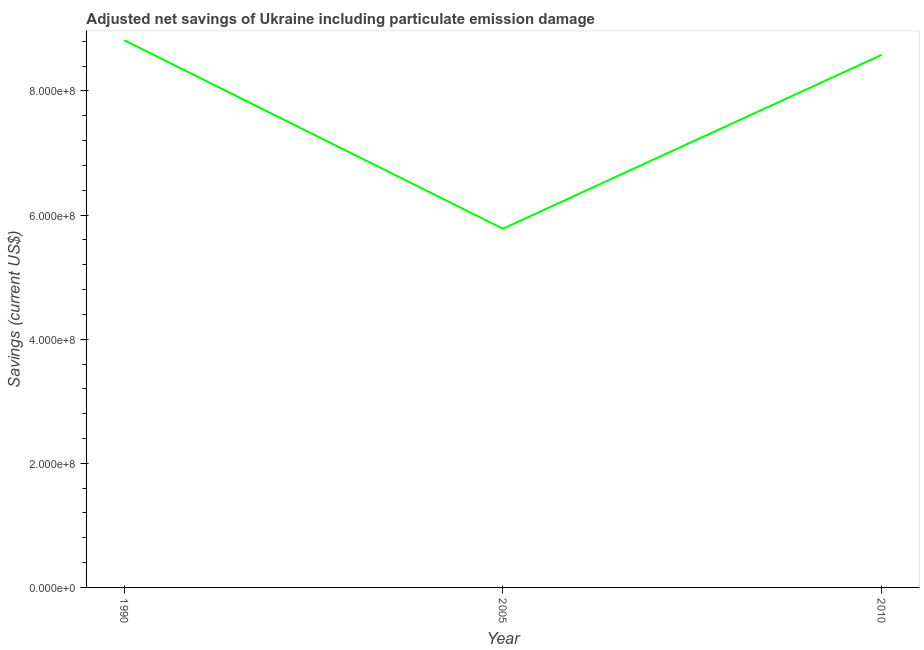What is the adjusted net savings in 2005?
Your response must be concise. 5.78e+08. Across all years, what is the maximum adjusted net savings?
Offer a very short reply. 8.82e+08. Across all years, what is the minimum adjusted net savings?
Ensure brevity in your answer.  5.78e+08. In which year was the adjusted net savings maximum?
Your response must be concise. 1990. In which year was the adjusted net savings minimum?
Give a very brief answer. 2005. What is the sum of the adjusted net savings?
Give a very brief answer. 2.32e+09. What is the difference between the adjusted net savings in 1990 and 2010?
Your answer should be compact. 2.36e+07. What is the average adjusted net savings per year?
Give a very brief answer. 7.73e+08. What is the median adjusted net savings?
Your answer should be very brief. 8.58e+08. Do a majority of the years between 1990 and 2010 (inclusive) have adjusted net savings greater than 120000000 US$?
Make the answer very short. Yes. What is the ratio of the adjusted net savings in 1990 to that in 2010?
Your response must be concise. 1.03. Is the adjusted net savings in 2005 less than that in 2010?
Provide a succinct answer. Yes. What is the difference between the highest and the second highest adjusted net savings?
Make the answer very short. 2.36e+07. Is the sum of the adjusted net savings in 1990 and 2010 greater than the maximum adjusted net savings across all years?
Give a very brief answer. Yes. What is the difference between the highest and the lowest adjusted net savings?
Give a very brief answer. 3.04e+08. In how many years, is the adjusted net savings greater than the average adjusted net savings taken over all years?
Make the answer very short. 2. How many lines are there?
Keep it short and to the point. 1. How many years are there in the graph?
Your answer should be compact. 3. Does the graph contain grids?
Your answer should be compact. No. What is the title of the graph?
Your response must be concise. Adjusted net savings of Ukraine including particulate emission damage. What is the label or title of the X-axis?
Your answer should be compact. Year. What is the label or title of the Y-axis?
Offer a very short reply. Savings (current US$). What is the Savings (current US$) of 1990?
Ensure brevity in your answer.  8.82e+08. What is the Savings (current US$) of 2005?
Your answer should be very brief. 5.78e+08. What is the Savings (current US$) in 2010?
Provide a succinct answer. 8.58e+08. What is the difference between the Savings (current US$) in 1990 and 2005?
Provide a short and direct response. 3.04e+08. What is the difference between the Savings (current US$) in 1990 and 2010?
Keep it short and to the point. 2.36e+07. What is the difference between the Savings (current US$) in 2005 and 2010?
Provide a succinct answer. -2.80e+08. What is the ratio of the Savings (current US$) in 1990 to that in 2005?
Offer a terse response. 1.52. What is the ratio of the Savings (current US$) in 1990 to that in 2010?
Your answer should be compact. 1.03. What is the ratio of the Savings (current US$) in 2005 to that in 2010?
Ensure brevity in your answer.  0.67. 